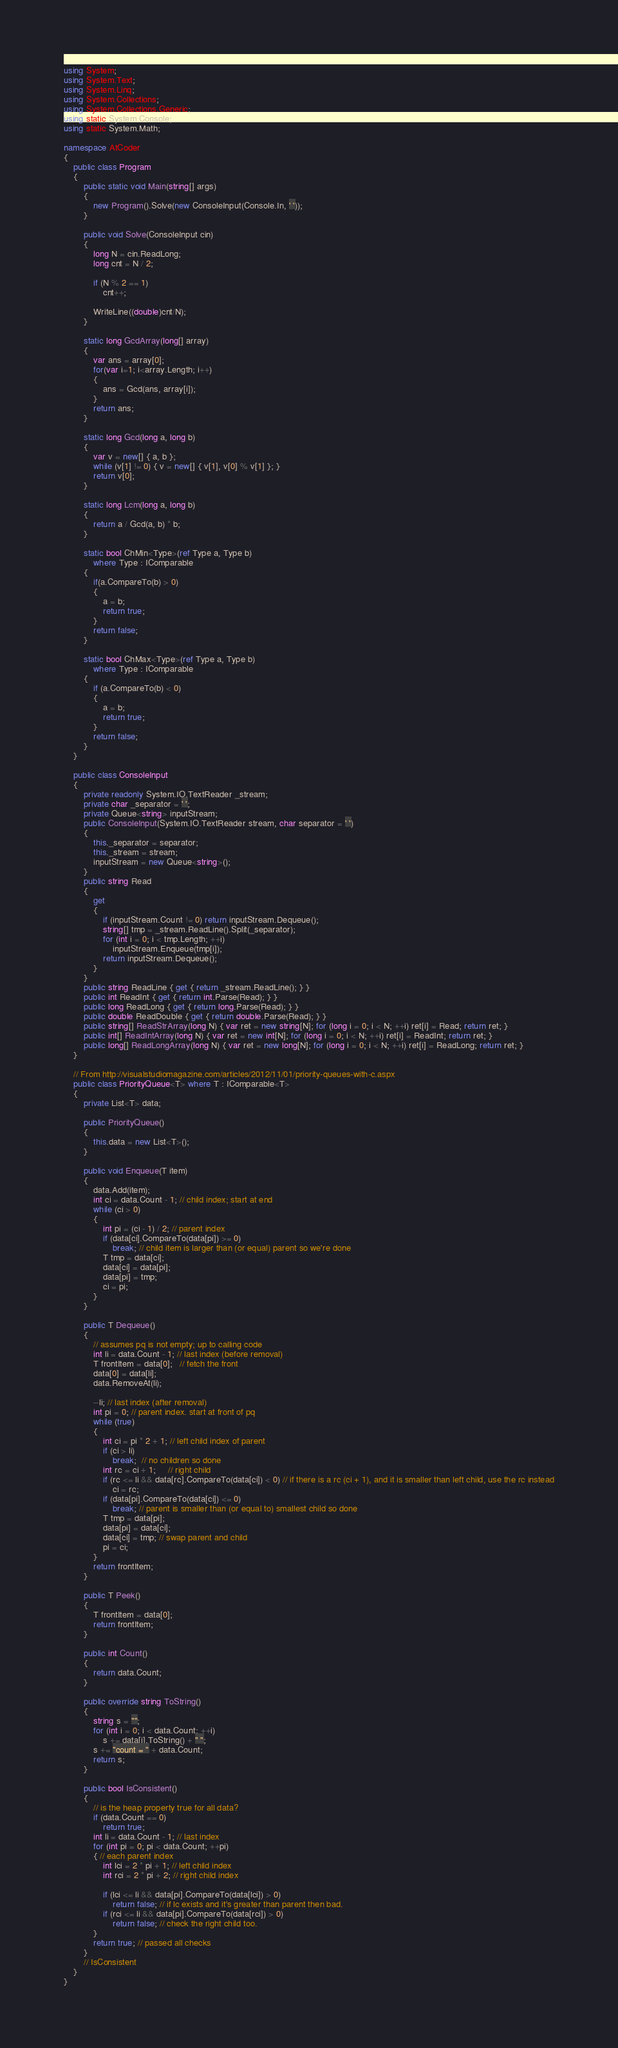Convert code to text. <code><loc_0><loc_0><loc_500><loc_500><_C#_>using System;
using System.Text;
using System.Linq;
using System.Collections;
using System.Collections.Generic;
using static System.Console;
using static System.Math;

namespace AtCoder
{
    public class Program
    {
        public static void Main(string[] args)
        {
            new Program().Solve(new ConsoleInput(Console.In, ' '));
        }

        public void Solve(ConsoleInput cin)
        {
            long N = cin.ReadLong;
            long cnt = N / 2;

            if (N % 2 == 1)
                cnt++;

            WriteLine((double)cnt/N);
        }

        static long GcdArray(long[] array)
        {
            var ans = array[0];
            for(var i=1; i<array.Length; i++)
            {
                ans = Gcd(ans, array[i]);
            }
            return ans;
        }

        static long Gcd(long a, long b)
        {
            var v = new[] { a, b };
            while (v[1] != 0) { v = new[] { v[1], v[0] % v[1] }; }
            return v[0];
        }

        static long Lcm(long a, long b)
        {
            return a / Gcd(a, b) * b;
        }

        static bool ChMin<Type>(ref Type a, Type b)
            where Type : IComparable
        {   
            if(a.CompareTo(b) > 0)
            {
                a = b;
                return true;
            }
            return false;
        }

        static bool ChMax<Type>(ref Type a, Type b)
            where Type : IComparable
        {
            if (a.CompareTo(b) < 0)
            {
                a = b;
                return true;
            }
            return false;
        }
    }

    public class ConsoleInput
    {
        private readonly System.IO.TextReader _stream;
        private char _separator = ' ';
        private Queue<string> inputStream;
        public ConsoleInput(System.IO.TextReader stream, char separator = ' ')
        {
            this._separator = separator;
            this._stream = stream;
            inputStream = new Queue<string>();
        }
        public string Read
        {
            get
            {
                if (inputStream.Count != 0) return inputStream.Dequeue();
                string[] tmp = _stream.ReadLine().Split(_separator);
                for (int i = 0; i < tmp.Length; ++i)
                    inputStream.Enqueue(tmp[i]);
                return inputStream.Dequeue();
            }
        }
        public string ReadLine { get { return _stream.ReadLine(); } }
        public int ReadInt { get { return int.Parse(Read); } }
        public long ReadLong { get { return long.Parse(Read); } }
        public double ReadDouble { get { return double.Parse(Read); } }
        public string[] ReadStrArray(long N) { var ret = new string[N]; for (long i = 0; i < N; ++i) ret[i] = Read; return ret; }
        public int[] ReadIntArray(long N) { var ret = new int[N]; for (long i = 0; i < N; ++i) ret[i] = ReadInt; return ret; }
        public long[] ReadLongArray(long N) { var ret = new long[N]; for (long i = 0; i < N; ++i) ret[i] = ReadLong; return ret; }
    }

    // From http://visualstudiomagazine.com/articles/2012/11/01/priority-queues-with-c.aspx
    public class PriorityQueue<T> where T : IComparable<T>
    {
        private List<T> data;

        public PriorityQueue()
        {
            this.data = new List<T>();
        }

        public void Enqueue(T item)
        {
            data.Add(item);
            int ci = data.Count - 1; // child index; start at end
            while (ci > 0)
            {
                int pi = (ci - 1) / 2; // parent index
                if (data[ci].CompareTo(data[pi]) >= 0)
                    break; // child item is larger than (or equal) parent so we're done
                T tmp = data[ci];
                data[ci] = data[pi];
                data[pi] = tmp;
                ci = pi;
            }
        }

        public T Dequeue()
        {
            // assumes pq is not empty; up to calling code
            int li = data.Count - 1; // last index (before removal)
            T frontItem = data[0];   // fetch the front
            data[0] = data[li];
            data.RemoveAt(li);

            --li; // last index (after removal)
            int pi = 0; // parent index. start at front of pq
            while (true)
            {
                int ci = pi * 2 + 1; // left child index of parent
                if (ci > li)
                    break;  // no children so done
                int rc = ci + 1;     // right child
                if (rc <= li && data[rc].CompareTo(data[ci]) < 0) // if there is a rc (ci + 1), and it is smaller than left child, use the rc instead
                    ci = rc;
                if (data[pi].CompareTo(data[ci]) <= 0)
                    break; // parent is smaller than (or equal to) smallest child so done
                T tmp = data[pi];
                data[pi] = data[ci];
                data[ci] = tmp; // swap parent and child
                pi = ci;
            }
            return frontItem;
        }

        public T Peek()
        {
            T frontItem = data[0];
            return frontItem;
        }

        public int Count()
        {
            return data.Count;
        }

        public override string ToString()
        {
            string s = "";
            for (int i = 0; i < data.Count; ++i)
                s += data[i].ToString() + " ";
            s += "count = " + data.Count;
            return s;
        }

        public bool IsConsistent()
        {
            // is the heap property true for all data?
            if (data.Count == 0)
                return true;
            int li = data.Count - 1; // last index
            for (int pi = 0; pi < data.Count; ++pi)
            { // each parent index
                int lci = 2 * pi + 1; // left child index
                int rci = 2 * pi + 2; // right child index

                if (lci <= li && data[pi].CompareTo(data[lci]) > 0)
                    return false; // if lc exists and it's greater than parent then bad.
                if (rci <= li && data[pi].CompareTo(data[rci]) > 0)
                    return false; // check the right child too.
            }
            return true; // passed all checks
        }
        // IsConsistent
    }
}</code> 